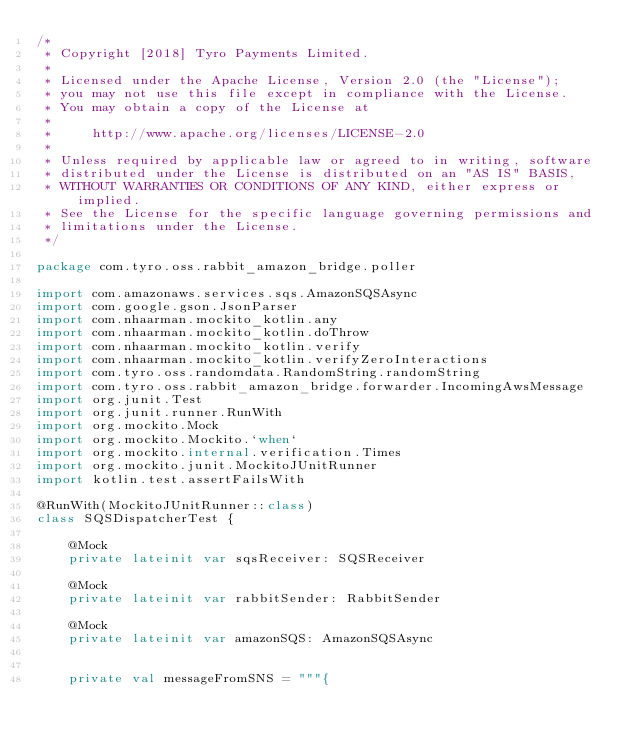<code> <loc_0><loc_0><loc_500><loc_500><_Kotlin_>/*
 * Copyright [2018] Tyro Payments Limited.
 *
 * Licensed under the Apache License, Version 2.0 (the "License");
 * you may not use this file except in compliance with the License.
 * You may obtain a copy of the License at
 *
 *     http://www.apache.org/licenses/LICENSE-2.0
 *
 * Unless required by applicable law or agreed to in writing, software
 * distributed under the License is distributed on an "AS IS" BASIS,
 * WITHOUT WARRANTIES OR CONDITIONS OF ANY KIND, either express or implied.
 * See the License for the specific language governing permissions and
 * limitations under the License.
 */

package com.tyro.oss.rabbit_amazon_bridge.poller

import com.amazonaws.services.sqs.AmazonSQSAsync
import com.google.gson.JsonParser
import com.nhaarman.mockito_kotlin.any
import com.nhaarman.mockito_kotlin.doThrow
import com.nhaarman.mockito_kotlin.verify
import com.nhaarman.mockito_kotlin.verifyZeroInteractions
import com.tyro.oss.randomdata.RandomString.randomString
import com.tyro.oss.rabbit_amazon_bridge.forwarder.IncomingAwsMessage
import org.junit.Test
import org.junit.runner.RunWith
import org.mockito.Mock
import org.mockito.Mockito.`when`
import org.mockito.internal.verification.Times
import org.mockito.junit.MockitoJUnitRunner
import kotlin.test.assertFailsWith

@RunWith(MockitoJUnitRunner::class)
class SQSDispatcherTest {

    @Mock
    private lateinit var sqsReceiver: SQSReceiver

    @Mock
    private lateinit var rabbitSender: RabbitSender

    @Mock
    private lateinit var amazonSQS: AmazonSQSAsync


    private val messageFromSNS = """{</code> 